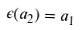<formula> <loc_0><loc_0><loc_500><loc_500>\epsilon ( a _ { 2 } ) = a _ { 1 }</formula> 